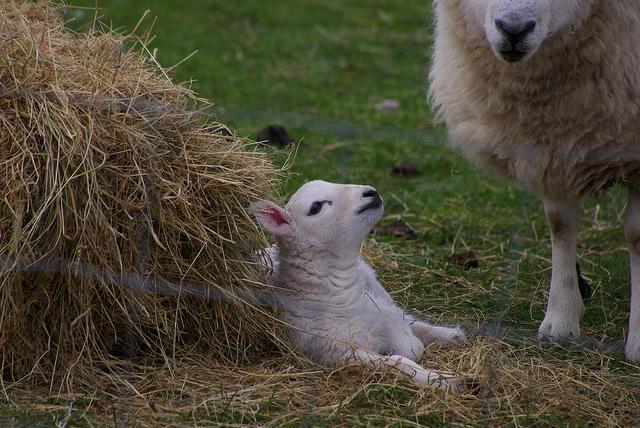How many baby animals are in this picture?
Give a very brief answer. 1. How many animals are there?
Give a very brief answer. 2. How many feet are visible in this picture?
Give a very brief answer. 4. How many eyes can be seen?
Give a very brief answer. 1. How many sheep are in the picture?
Give a very brief answer. 2. 